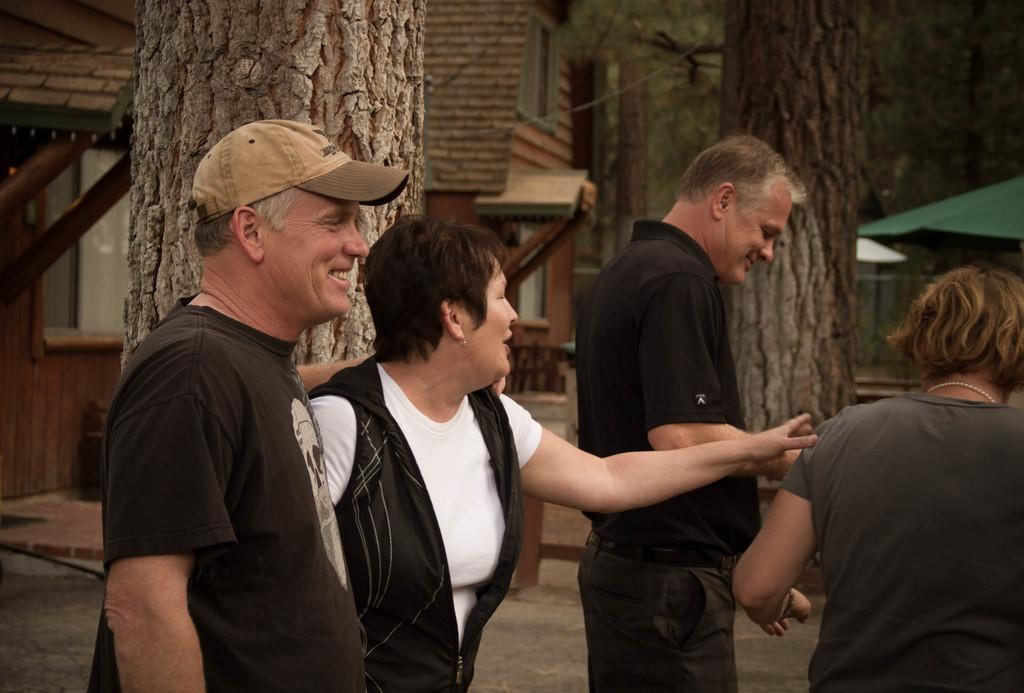How many people are present in the image? There are four people in the image. Can you describe the gender of the people in the image? Two of the people are men, and two are women. What can be seen in the background of the image? There are trees and houses in the background of the image. What type of wool is being used to make the spoon in the image? There is no spoon present in the image, and therefore no wool is being used to make it. What type of silk is being used to make the trees in the image? The trees in the image are not made of silk; they are natural trees. 